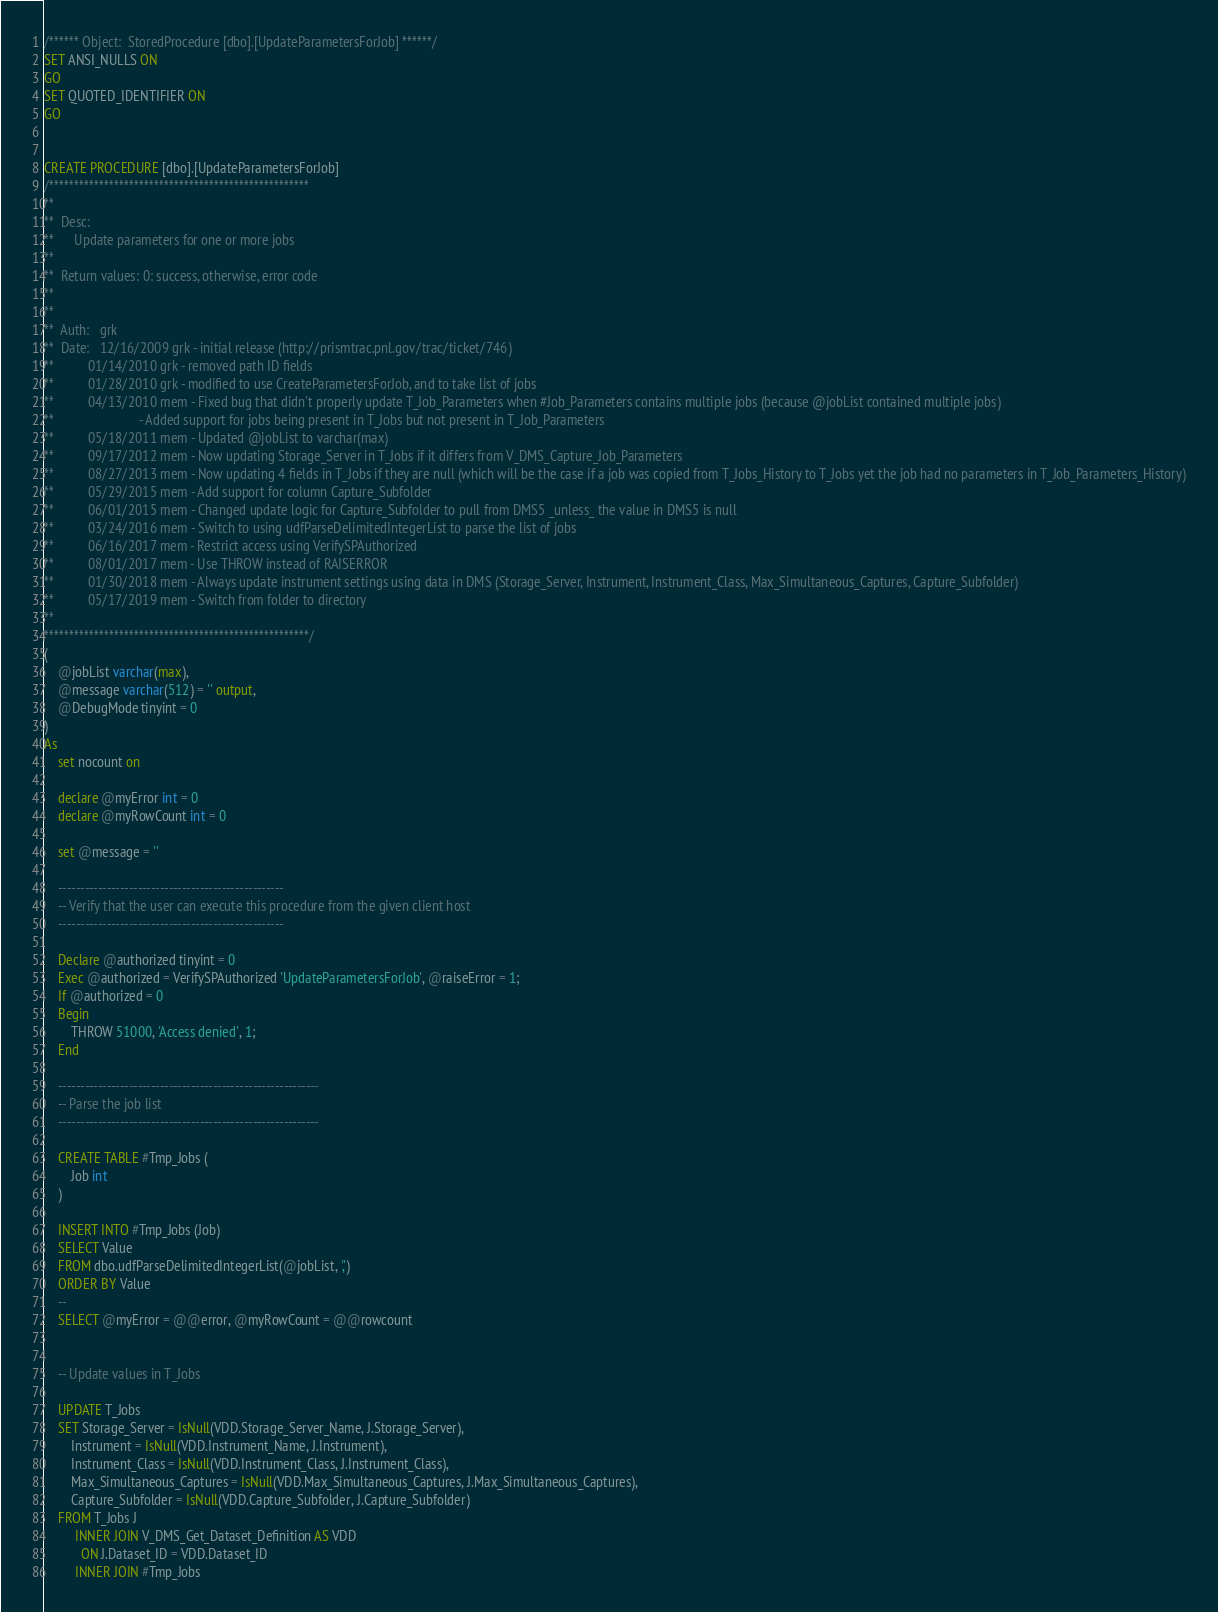<code> <loc_0><loc_0><loc_500><loc_500><_SQL_>/****** Object:  StoredProcedure [dbo].[UpdateParametersForJob] ******/
SET ANSI_NULLS ON
GO
SET QUOTED_IDENTIFIER ON
GO


CREATE PROCEDURE [dbo].[UpdateParametersForJob]
/****************************************************
**
**  Desc: 
**      Update parameters for one or more jobs
**    
**  Return values: 0: success, otherwise, error code
**
**
**  Auth:   grk
**  Date:   12/16/2009 grk - initial release (http://prismtrac.pnl.gov/trac/ticket/746)
**          01/14/2010 grk - removed path ID fields
**          01/28/2010 grk - modified to use CreateParametersForJob, and to take list of jobs
**          04/13/2010 mem - Fixed bug that didn't properly update T_Job_Parameters when #Job_Parameters contains multiple jobs (because @jobList contained multiple jobs)
**                         - Added support for jobs being present in T_Jobs but not present in T_Job_Parameters
**          05/18/2011 mem - Updated @jobList to varchar(max)
**          09/17/2012 mem - Now updating Storage_Server in T_Jobs if it differs from V_DMS_Capture_Job_Parameters
**          08/27/2013 mem - Now updating 4 fields in T_Jobs if they are null (which will be the case if a job was copied from T_Jobs_History to T_Jobs yet the job had no parameters in T_Job_Parameters_History)
**          05/29/2015 mem - Add support for column Capture_Subfolder
**          06/01/2015 mem - Changed update logic for Capture_Subfolder to pull from DMS5 _unless_ the value in DMS5 is null
**          03/24/2016 mem - Switch to using udfParseDelimitedIntegerList to parse the list of jobs
**          06/16/2017 mem - Restrict access using VerifySPAuthorized
**          08/01/2017 mem - Use THROW instead of RAISERROR
**          01/30/2018 mem - Always update instrument settings using data in DMS (Storage_Server, Instrument, Instrument_Class, Max_Simultaneous_Captures, Capture_Subfolder)
**          05/17/2019 mem - Switch from folder to directory
**  
*****************************************************/
(
    @jobList varchar(max),
    @message varchar(512) = '' output,
    @DebugMode tinyint = 0
)
As
    set nocount on
    
    declare @myError int = 0
    declare @myRowCount int = 0
    
    set @message = ''

    ---------------------------------------------------
    -- Verify that the user can execute this procedure from the given client host
    ---------------------------------------------------
        
    Declare @authorized tinyint = 0    
    Exec @authorized = VerifySPAuthorized 'UpdateParametersForJob', @raiseError = 1;
    If @authorized = 0
    Begin
        THROW 51000, 'Access denied', 1;
    End

    -----------------------------------------------------------
    -- Parse the job list
    -----------------------------------------------------------

    CREATE TABLE #Tmp_Jobs (
        Job int
    )

    INSERT INTO #Tmp_Jobs (Job)
    SELECT Value
    FROM dbo.udfParseDelimitedIntegerList(@jobList, ',')
    ORDER BY Value
    --
    SELECT @myError = @@error, @myRowCount = @@rowcount


    -- Update values in T_Jobs

    UPDATE T_Jobs
    SET Storage_Server = IsNull(VDD.Storage_Server_Name, J.Storage_Server),
        Instrument = IsNull(VDD.Instrument_Name, J.Instrument),
        Instrument_Class = IsNull(VDD.Instrument_Class, J.Instrument_Class),
        Max_Simultaneous_Captures = IsNull(VDD.Max_Simultaneous_Captures, J.Max_Simultaneous_Captures),
        Capture_Subfolder = IsNull(VDD.Capture_Subfolder, J.Capture_Subfolder)
    FROM T_Jobs J
         INNER JOIN V_DMS_Get_Dataset_Definition AS VDD
           ON J.Dataset_ID = VDD.Dataset_ID
         INNER JOIN #Tmp_Jobs</code> 